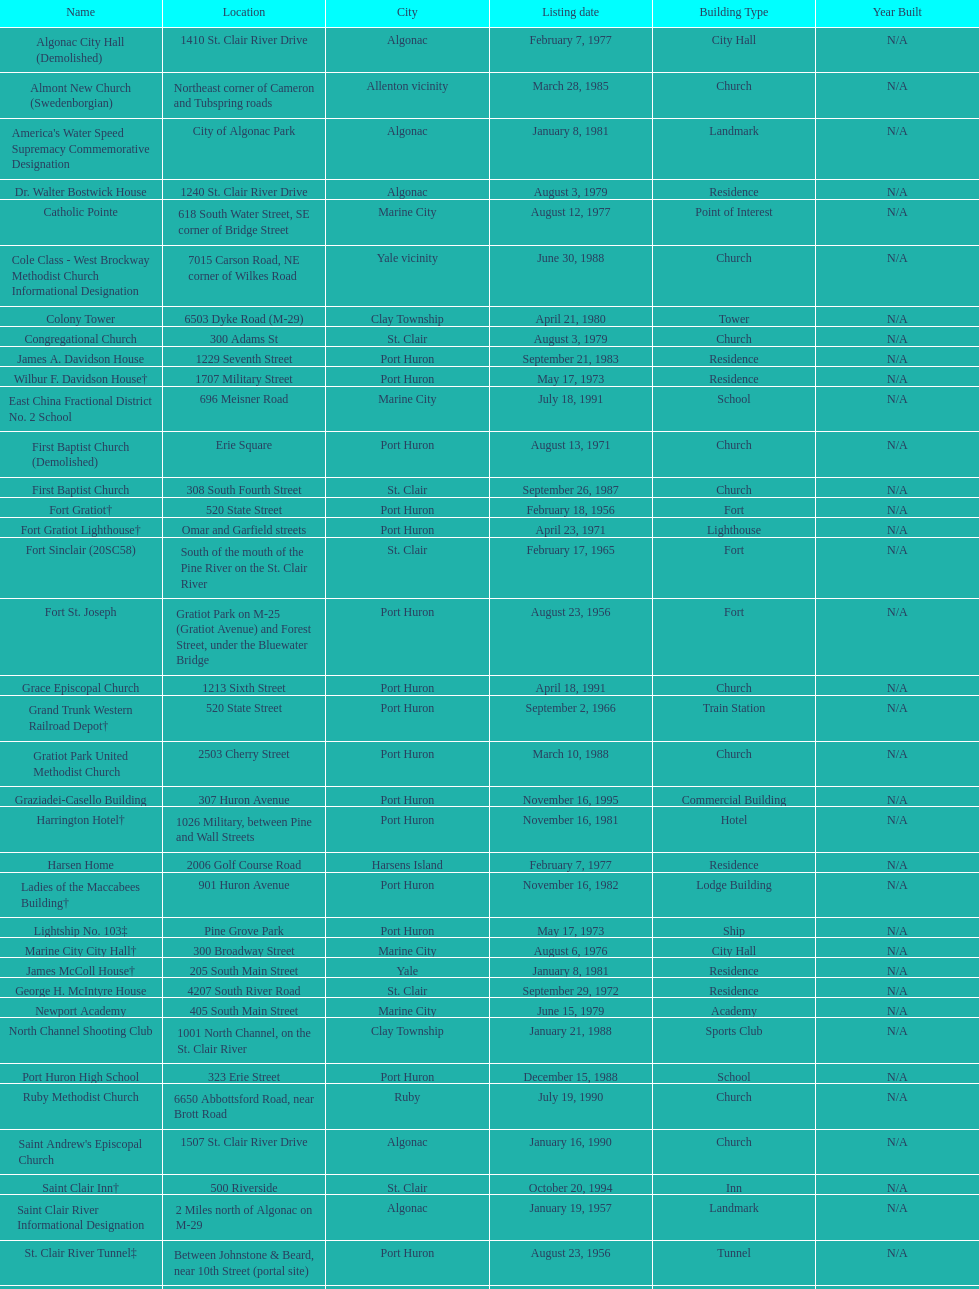Fort gratiot lighthouse and fort st. joseph are located in what city? Port Huron. 